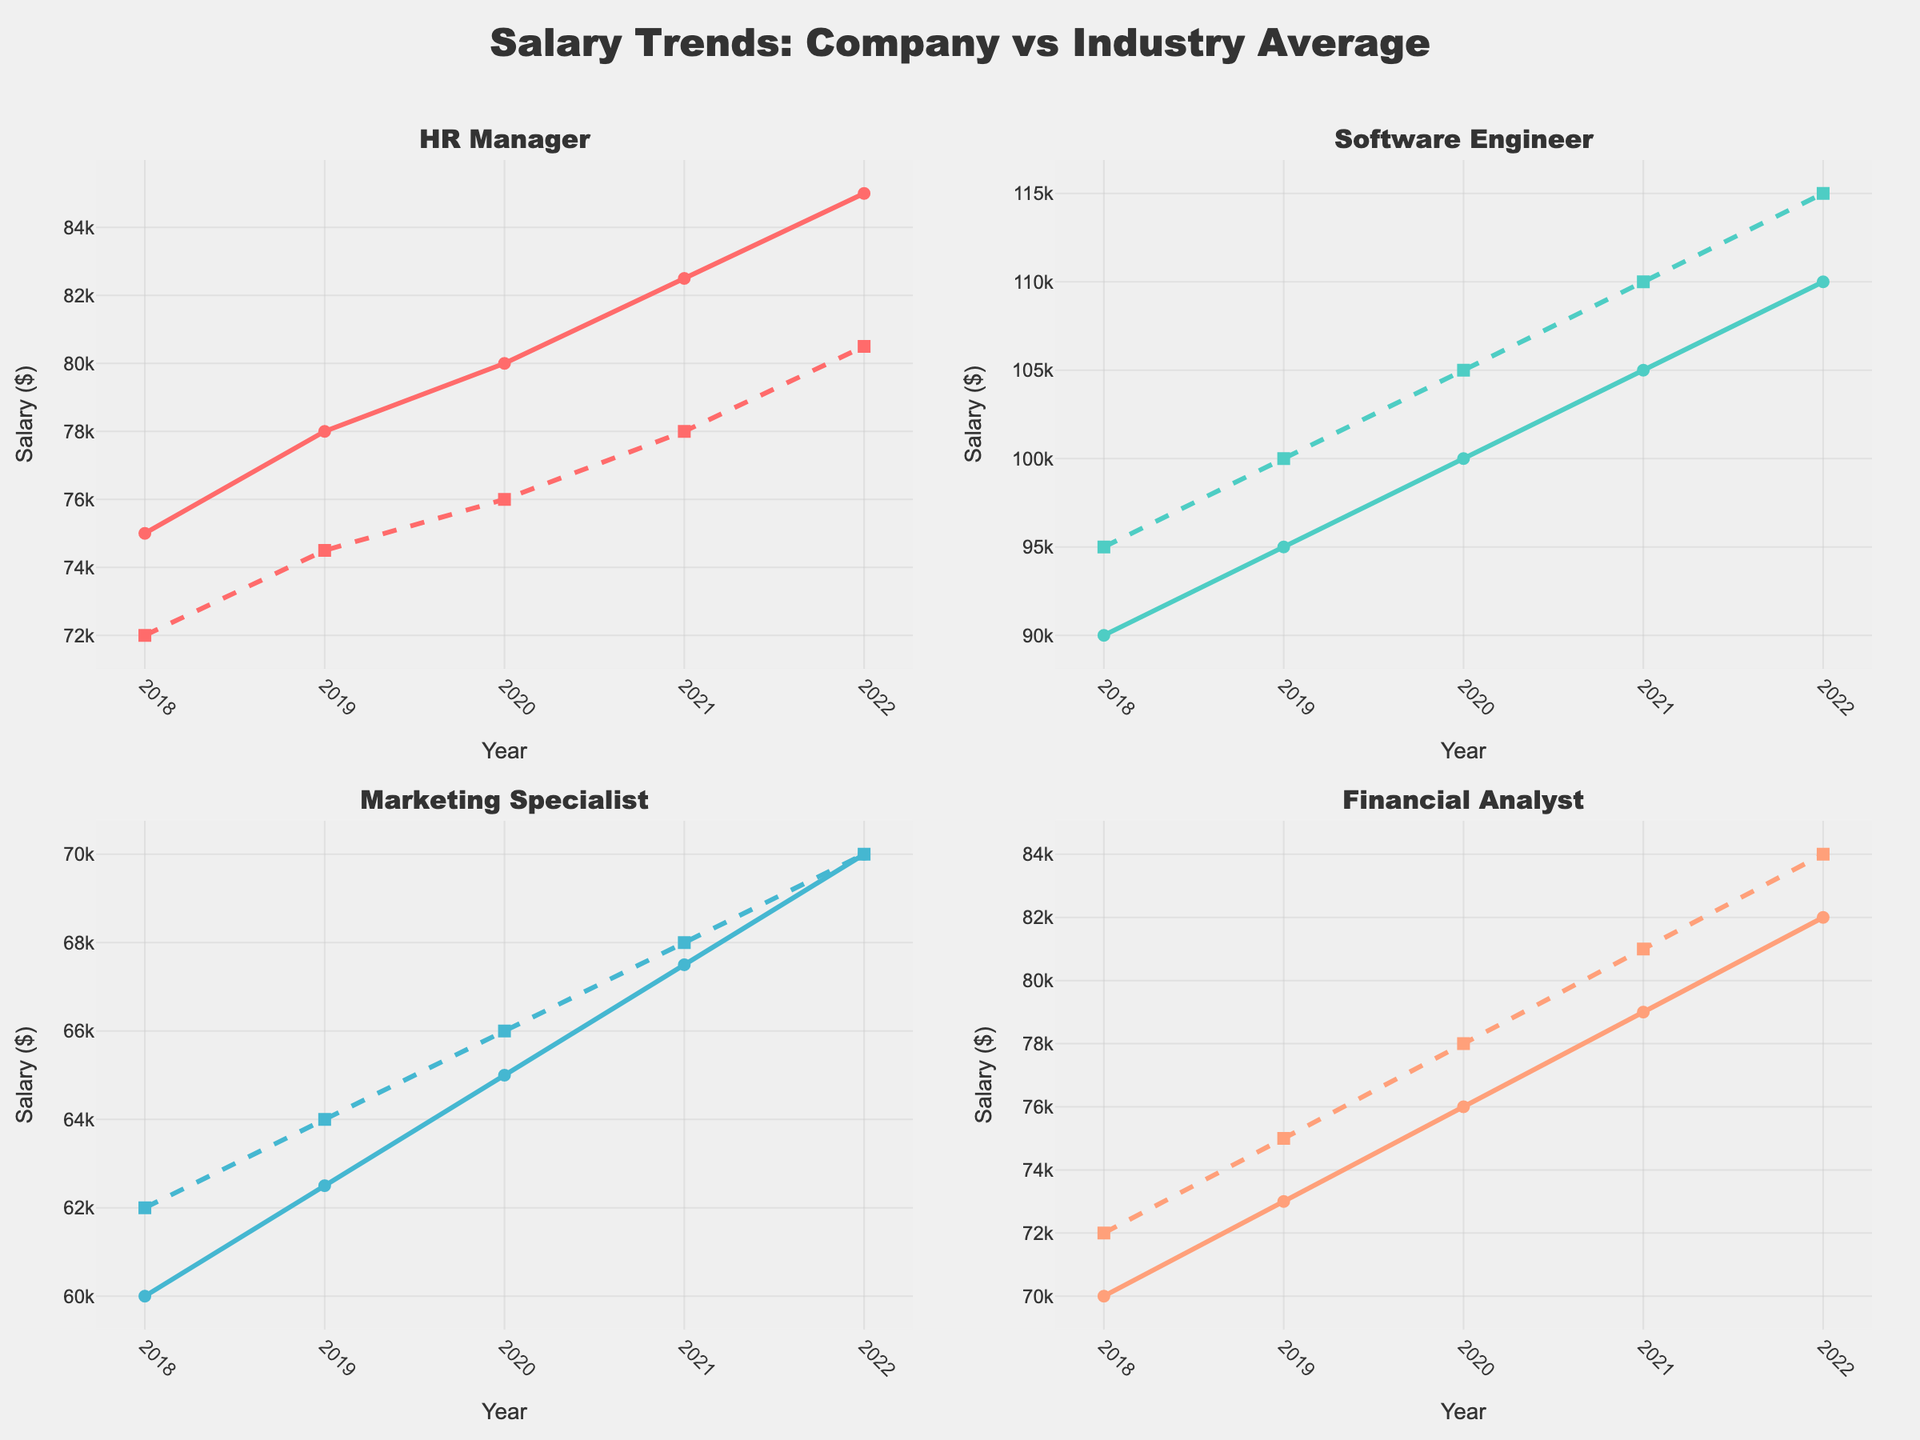What positions are being compared in the figure? The figure subplots show salary trends for different job positions. The subplot titles indicate which positions are being compared.
Answer: HR Manager, Software Engineer, Marketing Specialist, Financial Analyst What is the overall trend in company salary for HR Managers from 2018 to 2022? By looking at the line for Company Salary in the HR Manager subplot, we see a year-on-year increase in salary from $75,000 in 2018 to $85,000 in 2022.
Answer: The trend is consistently increasing How do the company salaries for Software Engineers compare to the industry average in 2022? In the Software Engineer subplot, observing the final data points for 2022 shows that company salaries are $110,000 while the industry average is $115,000.
Answer: Company salaries are lower by $5,000 What is the difference between the company salary and industry average for Financial Analysts in 2020? Look at the subplot for Financial Analysts, find the corresponding year (2020), and subtract the industry average ($78,000) from the company salary ($76,000).
Answer: $2,000 less Which position shows the closest alignment between company salary and industry average over the years? Comparing the trends and gaps between the lines in each subplot, the Marketing Specialist shows the closest alignment with almost parallel lines that closely match each other.
Answer: Marketing Specialist Which position had the highest company salary in 2019 and what was it? By examining the 2019 data points for each subplot, the highest company salary is for the Software Engineer position, which was $95,000.
Answer: Software Engineer, $95,000 Between which years did the HR Manager position see the greatest increase in company salary? Observing the slope of the lines in the HR Manager subplot, the steepest increase appears between 2021 and 2022, where the salary increased from $82,500 to $85,000.
Answer: 2021 to 2022 How does the trend of company salaries for Marketing Specialists compare to the industry average trend from 2018 to 2022? In the Marketing Specialist subplot, both the company salary and industry average lines increase, but the rate of increase is quite similar, showing parallel growth.
Answer: Similar, parallel growth What was the industry average salary for Financial Analysts in 2019? Locate the 2019 data point on the industry average line in the Financial Analyst subplot.
Answer: $75,000 